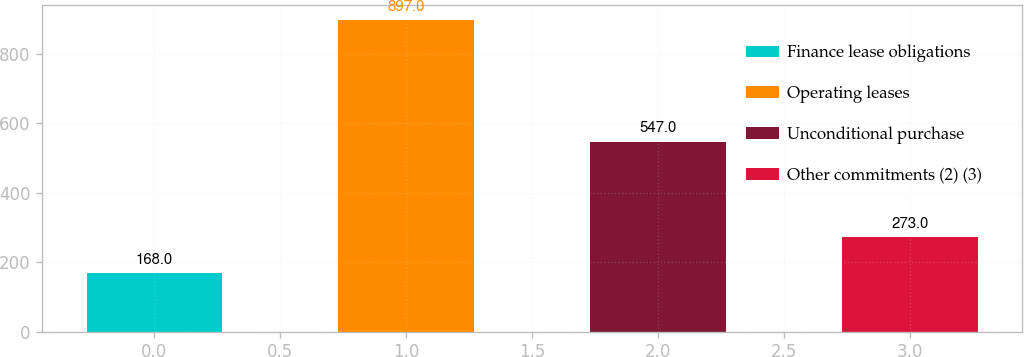Convert chart to OTSL. <chart><loc_0><loc_0><loc_500><loc_500><bar_chart><fcel>Finance lease obligations<fcel>Operating leases<fcel>Unconditional purchase<fcel>Other commitments (2) (3)<nl><fcel>168<fcel>897<fcel>547<fcel>273<nl></chart> 